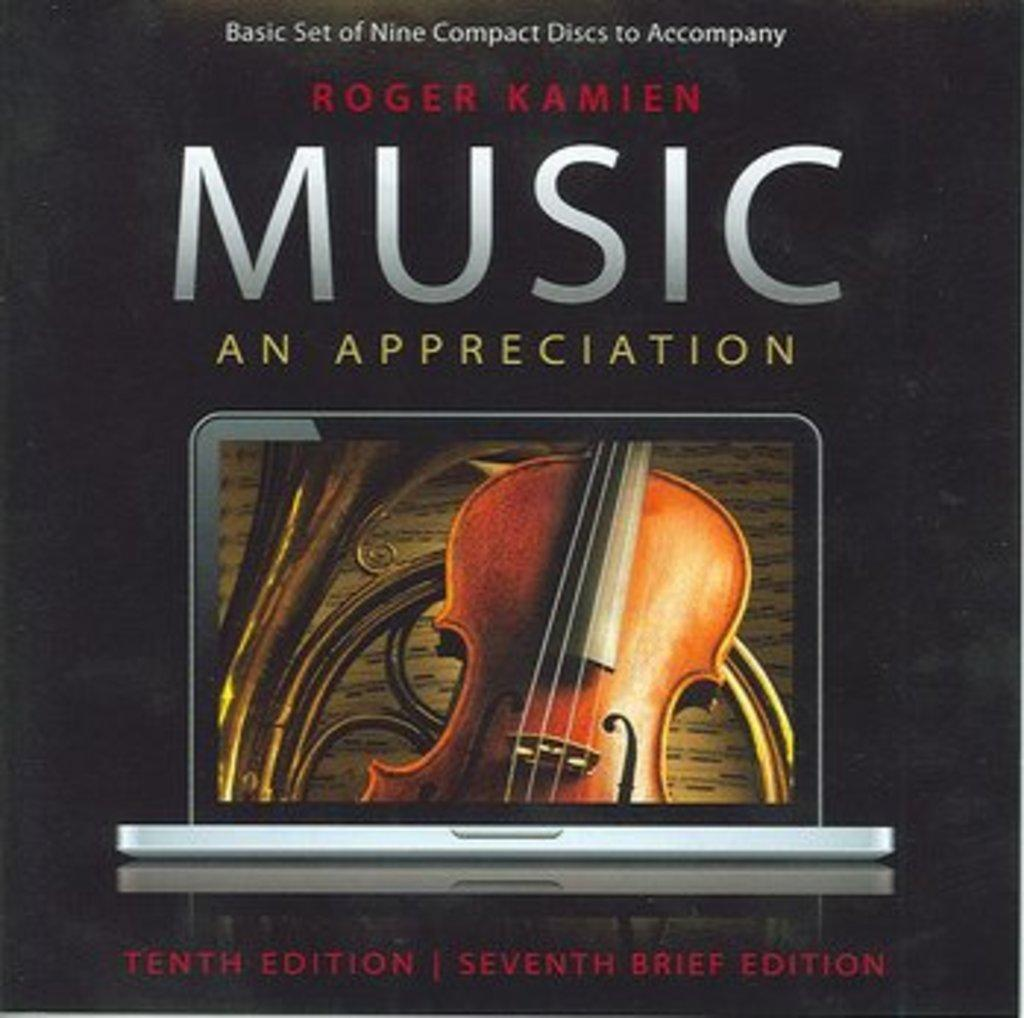<image>
Provide a brief description of the given image. Album cover by Roger Kamien for Music An Appreciation. 